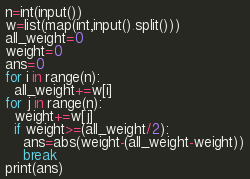Convert code to text. <code><loc_0><loc_0><loc_500><loc_500><_Python_>n=int(input())
w=list(map(int,input().split()))
all_weight=0
weight=0
ans=0
for i in range(n):
  all_weight+=w[i]
for j in range(n):
  weight+=w[j]
  if weight>=(all_weight/2):
    ans=abs(weight-(all_weight-weight))
    break
print(ans)</code> 